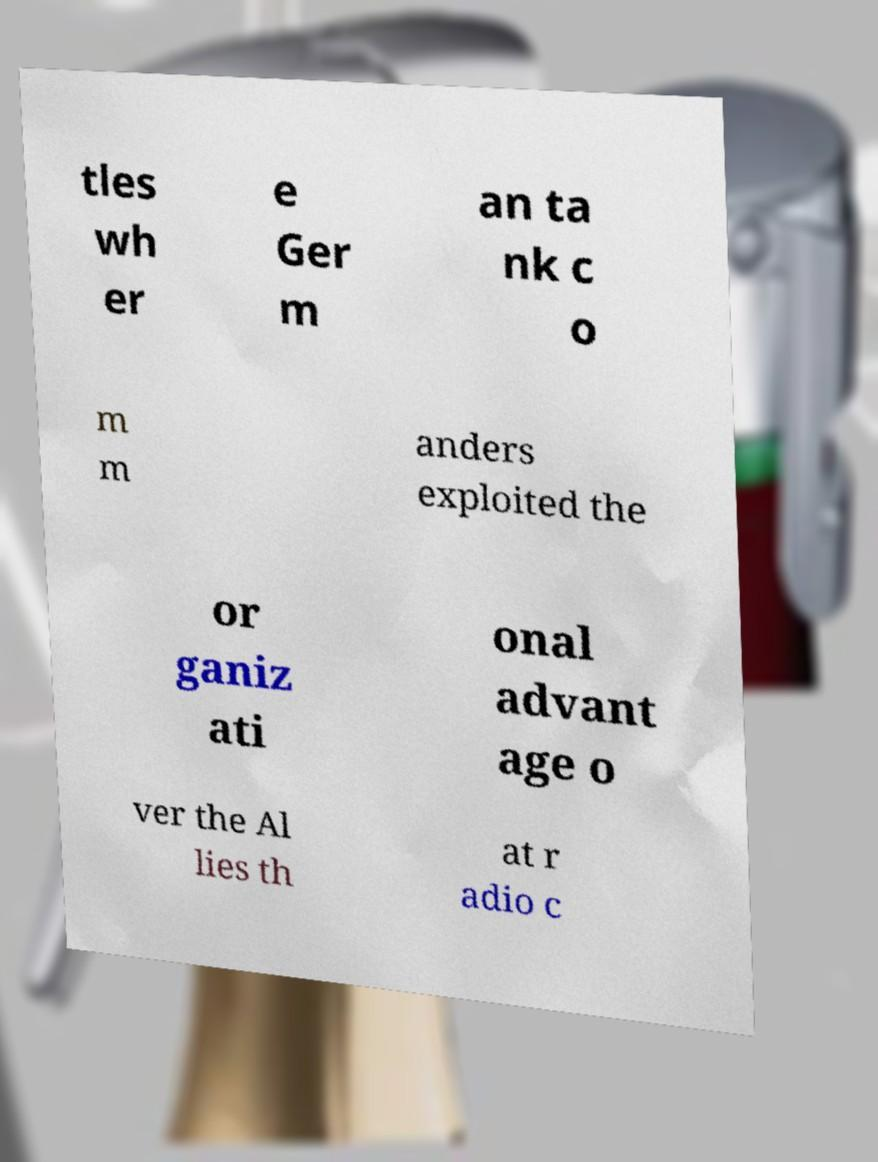Please read and relay the text visible in this image. What does it say? tles wh er e Ger m an ta nk c o m m anders exploited the or ganiz ati onal advant age o ver the Al lies th at r adio c 